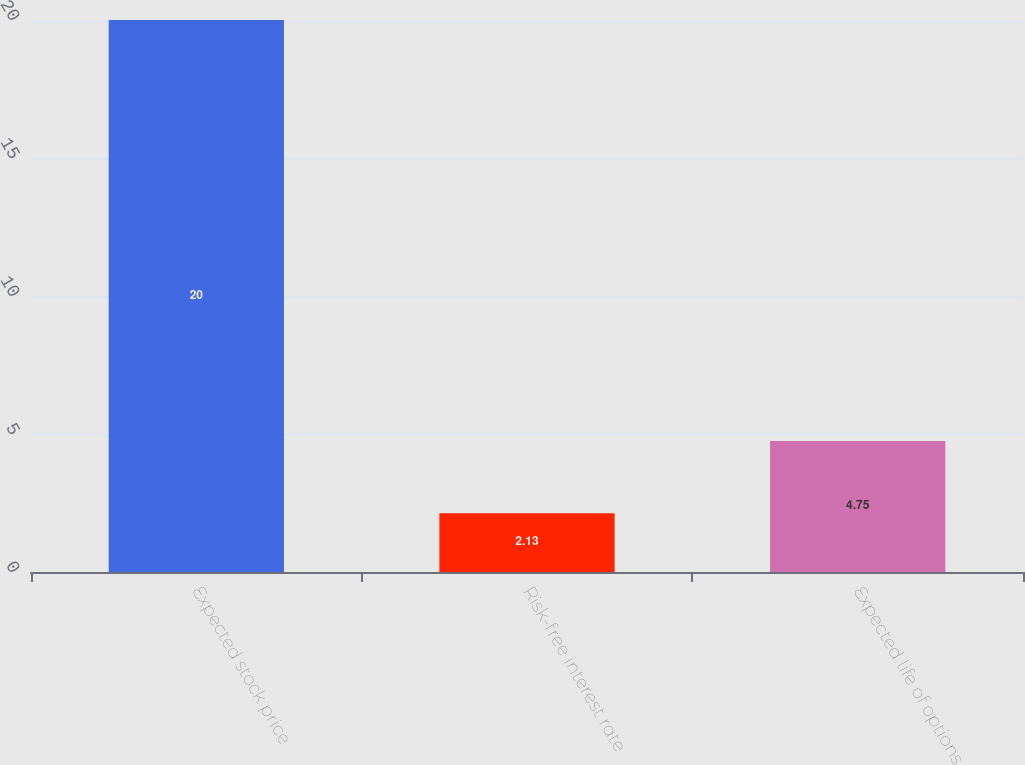Convert chart to OTSL. <chart><loc_0><loc_0><loc_500><loc_500><bar_chart><fcel>Expected stock price<fcel>Risk-free interest rate<fcel>Expected life of options<nl><fcel>20<fcel>2.13<fcel>4.75<nl></chart> 